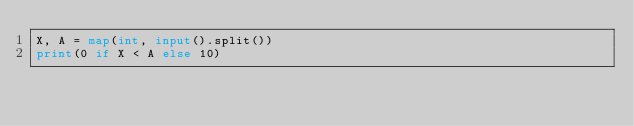<code> <loc_0><loc_0><loc_500><loc_500><_Python_>X, A = map(int, input().split())
print(0 if X < A else 10)</code> 